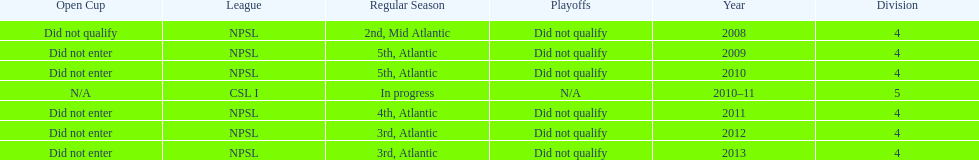In which most recent year did they rank 5th? 2010. 